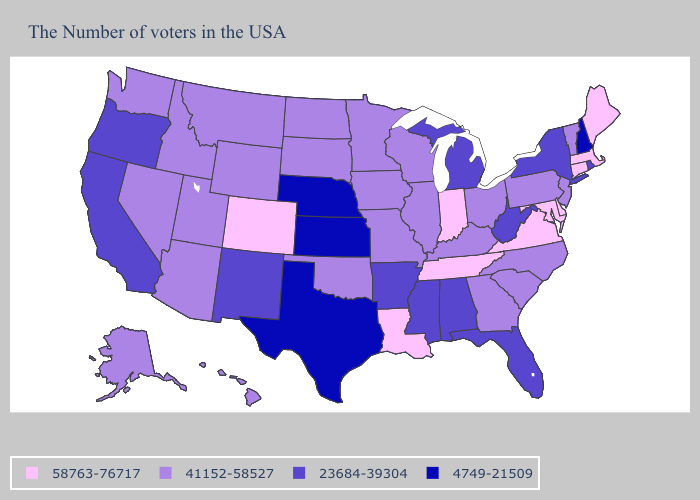What is the value of Nebraska?
Write a very short answer. 4749-21509. Among the states that border Louisiana , does Mississippi have the lowest value?
Short answer required. No. Which states have the lowest value in the South?
Write a very short answer. Texas. What is the value of Virginia?
Quick response, please. 58763-76717. Does Vermont have the highest value in the Northeast?
Keep it brief. No. Does Nevada have the highest value in the USA?
Quick response, please. No. What is the value of Pennsylvania?
Write a very short answer. 41152-58527. Does Illinois have the lowest value in the MidWest?
Quick response, please. No. Name the states that have a value in the range 23684-39304?
Short answer required. Rhode Island, New York, West Virginia, Florida, Michigan, Alabama, Mississippi, Arkansas, New Mexico, California, Oregon. Does the first symbol in the legend represent the smallest category?
Write a very short answer. No. Does Florida have the lowest value in the USA?
Answer briefly. No. Among the states that border Pennsylvania , which have the lowest value?
Quick response, please. New York, West Virginia. Name the states that have a value in the range 4749-21509?
Answer briefly. New Hampshire, Kansas, Nebraska, Texas. Does Illinois have the lowest value in the MidWest?
Concise answer only. No. 